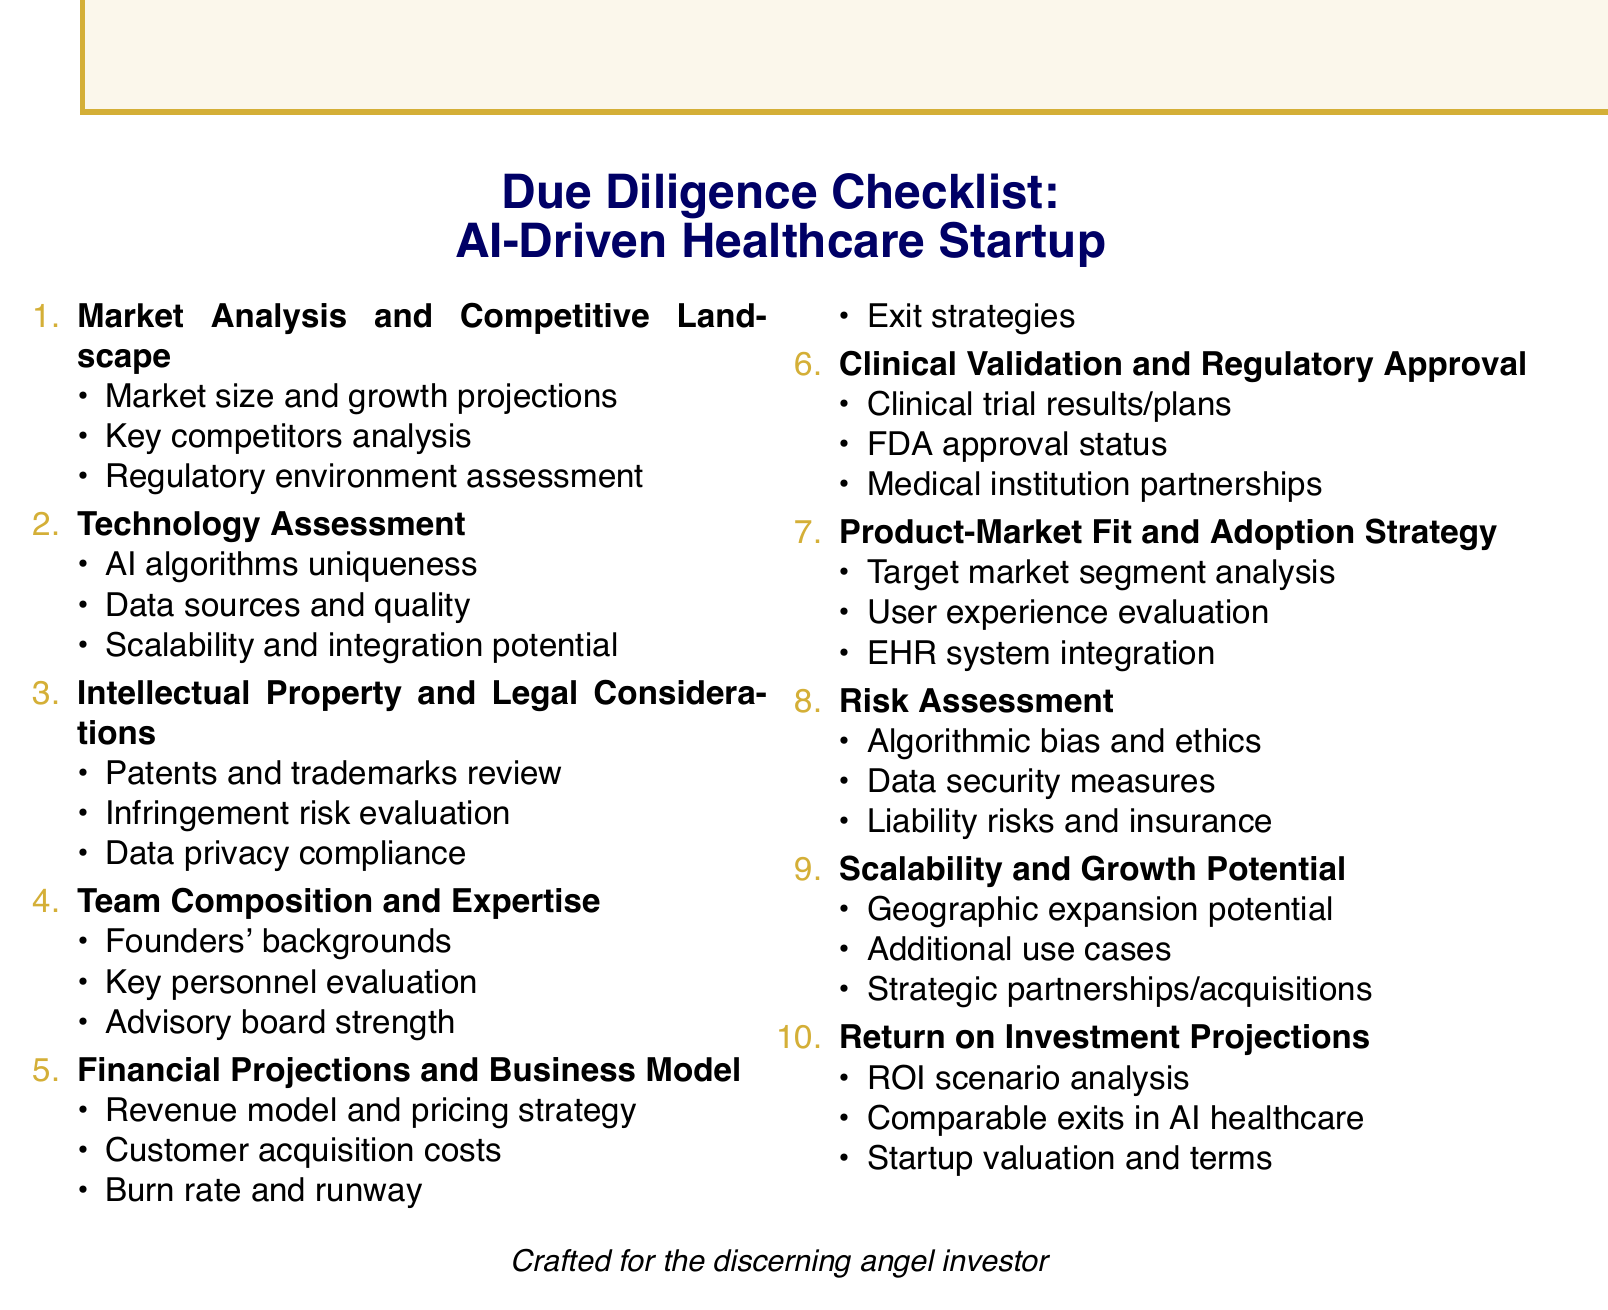What are key competitors mentioned? The document lists IBM Watson Health, Google Health, and Butterfly Network as key competitors in the AI healthcare space.
Answer: IBM Watson Health, Google Health, Butterfly Network What is being assessed in technology evaluation? The technology assessment involves examining the uniqueness of the startup's AI algorithms, validating data sources and quality, and assessing scalability and integration potential.
Answer: AI algorithms uniqueness, data sources and quality, scalability and integration potential What legal aspect is covered in the checklist? Intellectual property and legal considerations include reviewing patents, trademarks, trade secrets, evaluating potential infringement risks, and analyzing data privacy compliance.
Answer: Patents, trademarks, trade secrets What is the focus of the financial projections section? The financial projections and business model section reviews the revenue model, pricing strategy, customer acquisition costs, burn rate, and exit strategies.
Answer: Revenue model and pricing strategy, customer acquisition costs, burn rate and runway, exit strategies What is a primary concern in the risk assessment? The risk assessment includes evaluating potential algorithmic bias, ethical considerations, data security measures, and liability risks.
Answer: Algorithmic bias and ethical considerations What does the market analysis cover? The market analysis and competitive landscape section reviews the current AI healthcare market size, projected growth, key competitors, and regulatory environment.
Answer: Market size and growth projections, key competitors analysis, regulatory environment assessment Which institutions are mentioned for partnerships? The checklist assesses partnerships with leading medical institutions such as Mayo Clinic or Johns Hopkins in the clinical validation section.
Answer: Mayo Clinic, Johns Hopkins What is the potential for geographic expansion? The scalability and growth potential section evaluates the startup's potential for geographic expansion, additional use cases, and strategic partnerships.
Answer: Geographic expansion potential 